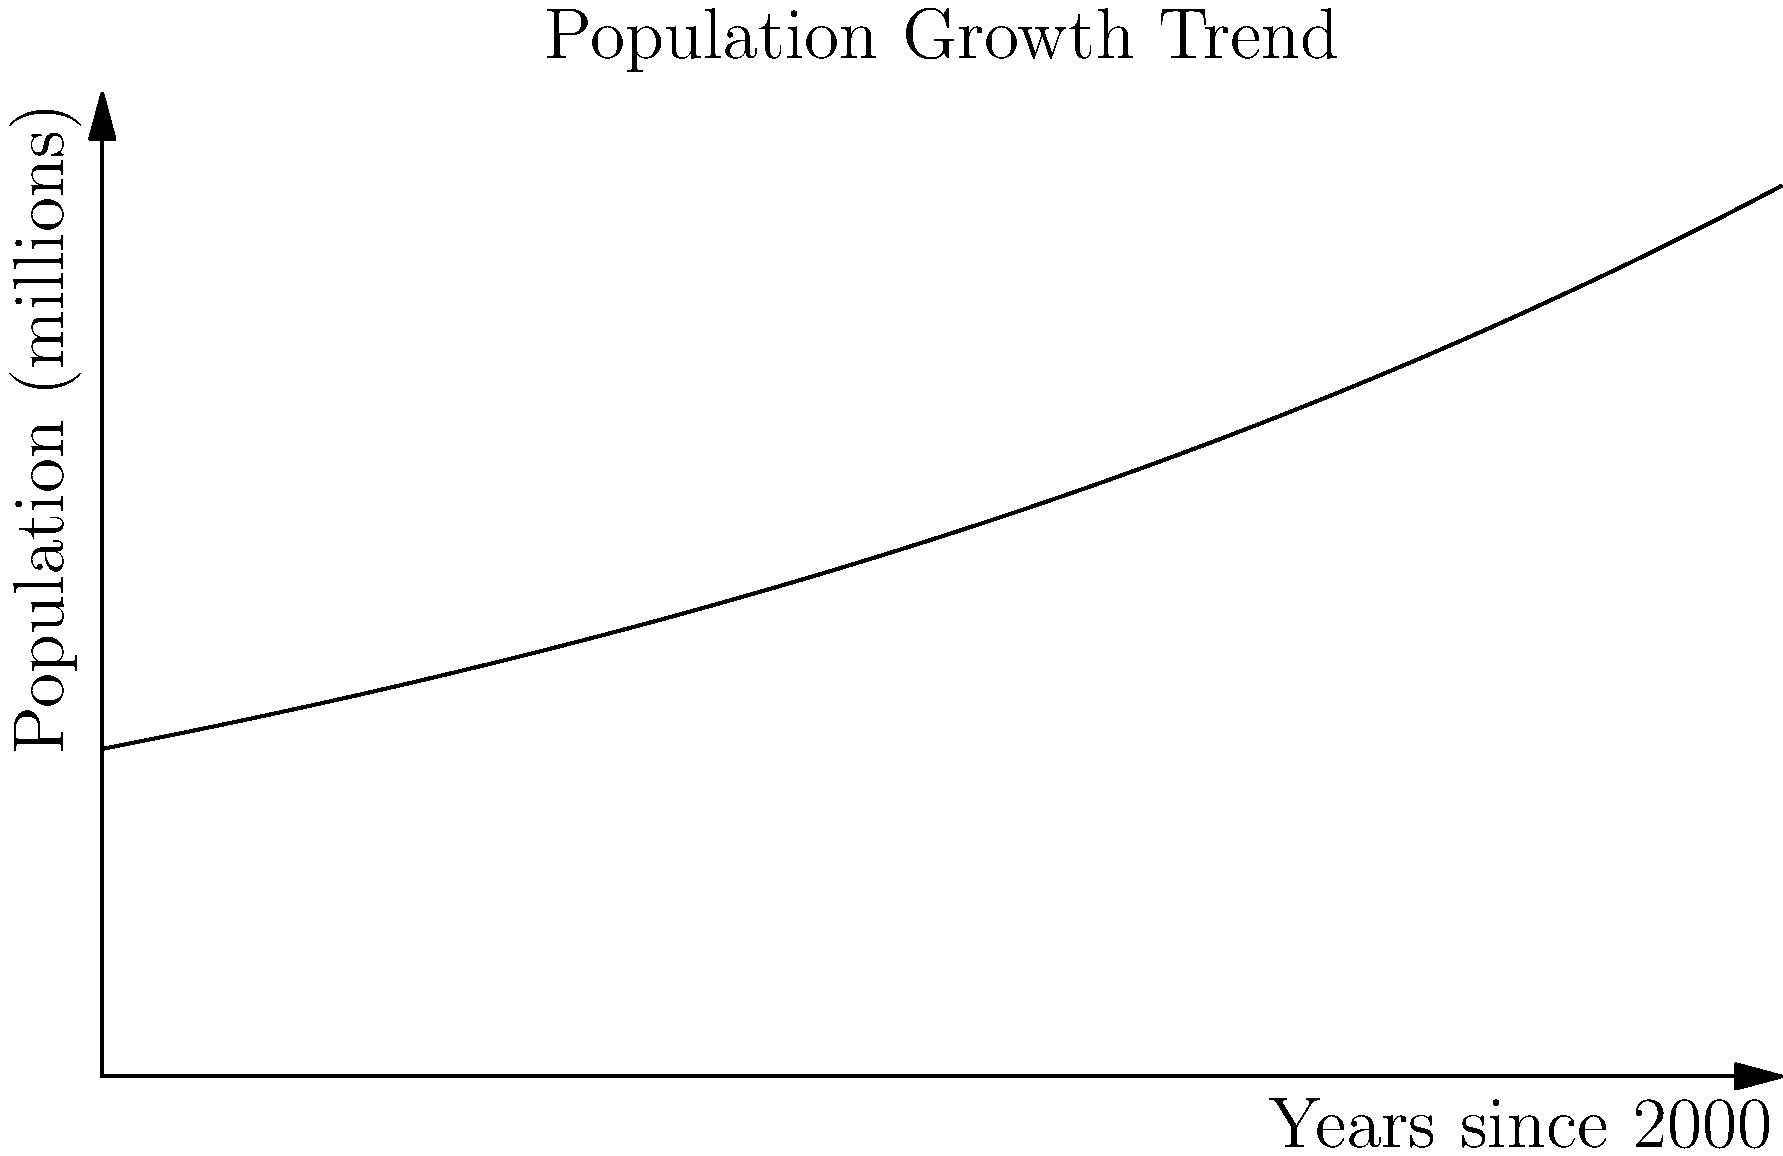The graph shows the population growth trend for a country over 50 years, starting from the year 2000. The population follows an exponential growth model given by $P(t) = 100e^{0.02t}$, where $P$ is the population in millions and $t$ is the time in years since 2000. Based on this model, in which year will the population reach 200 million? To find the year when the population reaches 200 million, we need to solve the equation:

1) $200 = 100e^{0.02t}$

2) Dividing both sides by 100:
   $2 = e^{0.02t}$

3) Taking the natural logarithm of both sides:
   $\ln(2) = 0.02t$

4) Solving for t:
   $t = \frac{\ln(2)}{0.02} \approx 34.66$ years

5) Since t represents years since 2000, we add this to 2000:
   $2000 + 34.66 \approx 2034.66$

6) Rounding to the nearest year, we get 2035.

This analysis shows that the population will reach 200 million in 2035, which is crucial information for long-term policy planning and resource allocation.
Answer: 2035 